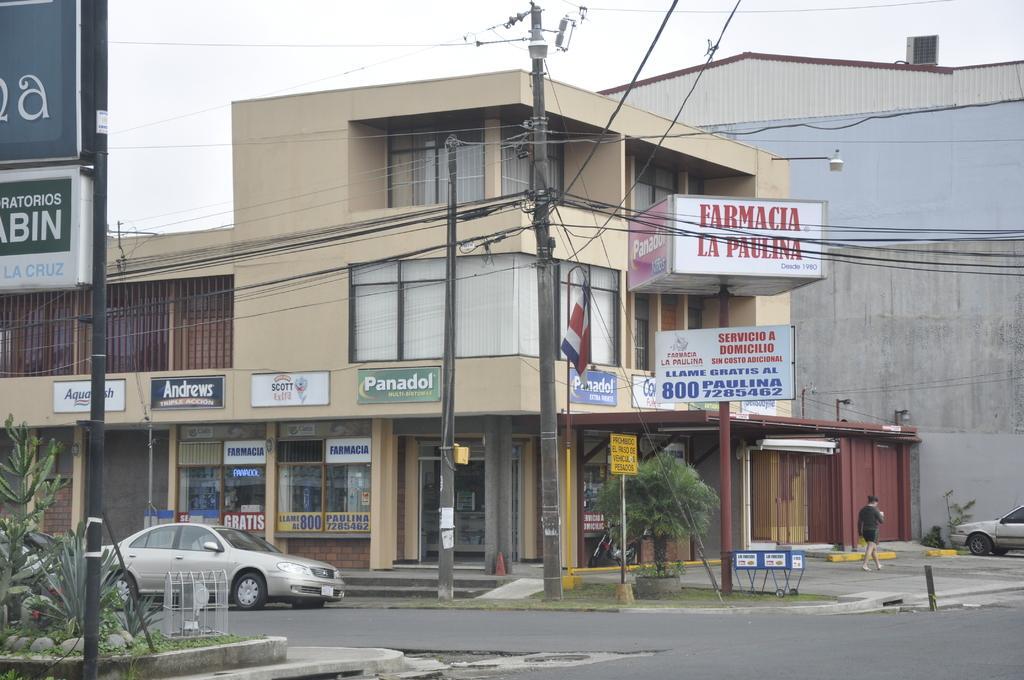How would you summarize this image in a sentence or two? As we can see in the image there are buildings, banners, current police, cars, a person walking over here and there is a sky. 